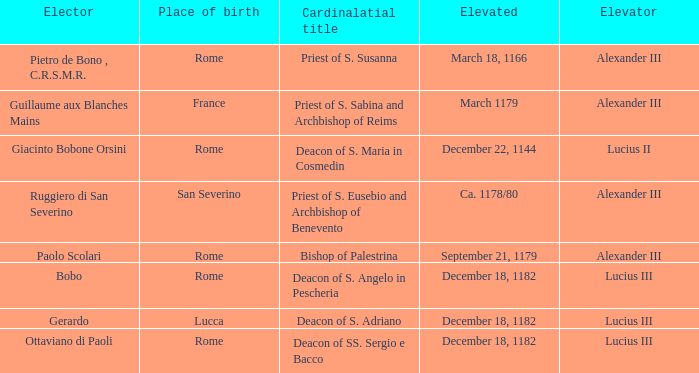Who is the Elector with a Cardinalatial title of Priest of S. Sabina and Archbishop of Reims? Guillaume aux Blanches Mains. 